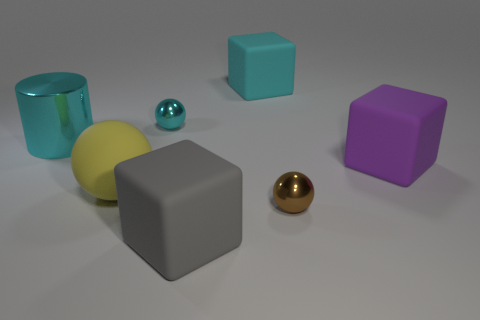Is there anything else that is the same size as the yellow matte ball?
Provide a succinct answer. Yes. What color is the matte object that is in front of the purple rubber object and to the right of the tiny cyan object?
Keep it short and to the point. Gray. Are the small object that is behind the brown metallic ball and the big gray block made of the same material?
Give a very brief answer. No. There is a cylinder; is it the same color as the big rubber cube that is behind the large cyan cylinder?
Make the answer very short. Yes. There is a big yellow matte object; are there any blocks behind it?
Offer a terse response. Yes. Does the cyan cube that is behind the big purple block have the same size as the metal sphere to the right of the cyan shiny ball?
Your answer should be very brief. No. Are there any cylinders of the same size as the cyan cube?
Your answer should be compact. Yes. Do the big rubber thing that is to the right of the cyan matte thing and the tiny cyan metal object have the same shape?
Offer a very short reply. No. There is a large block behind the big purple matte block; what is its material?
Your answer should be compact. Rubber. What shape is the cyan object behind the small object that is behind the big purple matte thing?
Keep it short and to the point. Cube. 